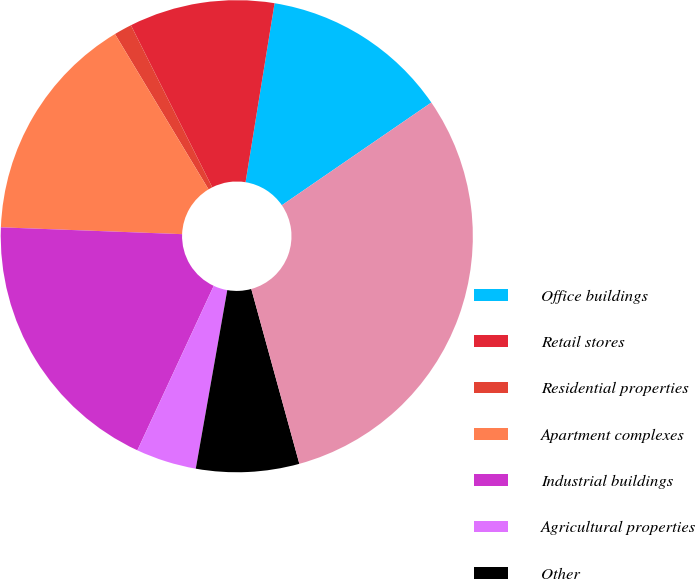<chart> <loc_0><loc_0><loc_500><loc_500><pie_chart><fcel>Office buildings<fcel>Retail stores<fcel>Residential properties<fcel>Apartment complexes<fcel>Industrial buildings<fcel>Agricultural properties<fcel>Other<fcel>Total collateralized loans<nl><fcel>12.86%<fcel>9.96%<fcel>1.23%<fcel>15.77%<fcel>18.68%<fcel>4.14%<fcel>7.05%<fcel>30.31%<nl></chart> 